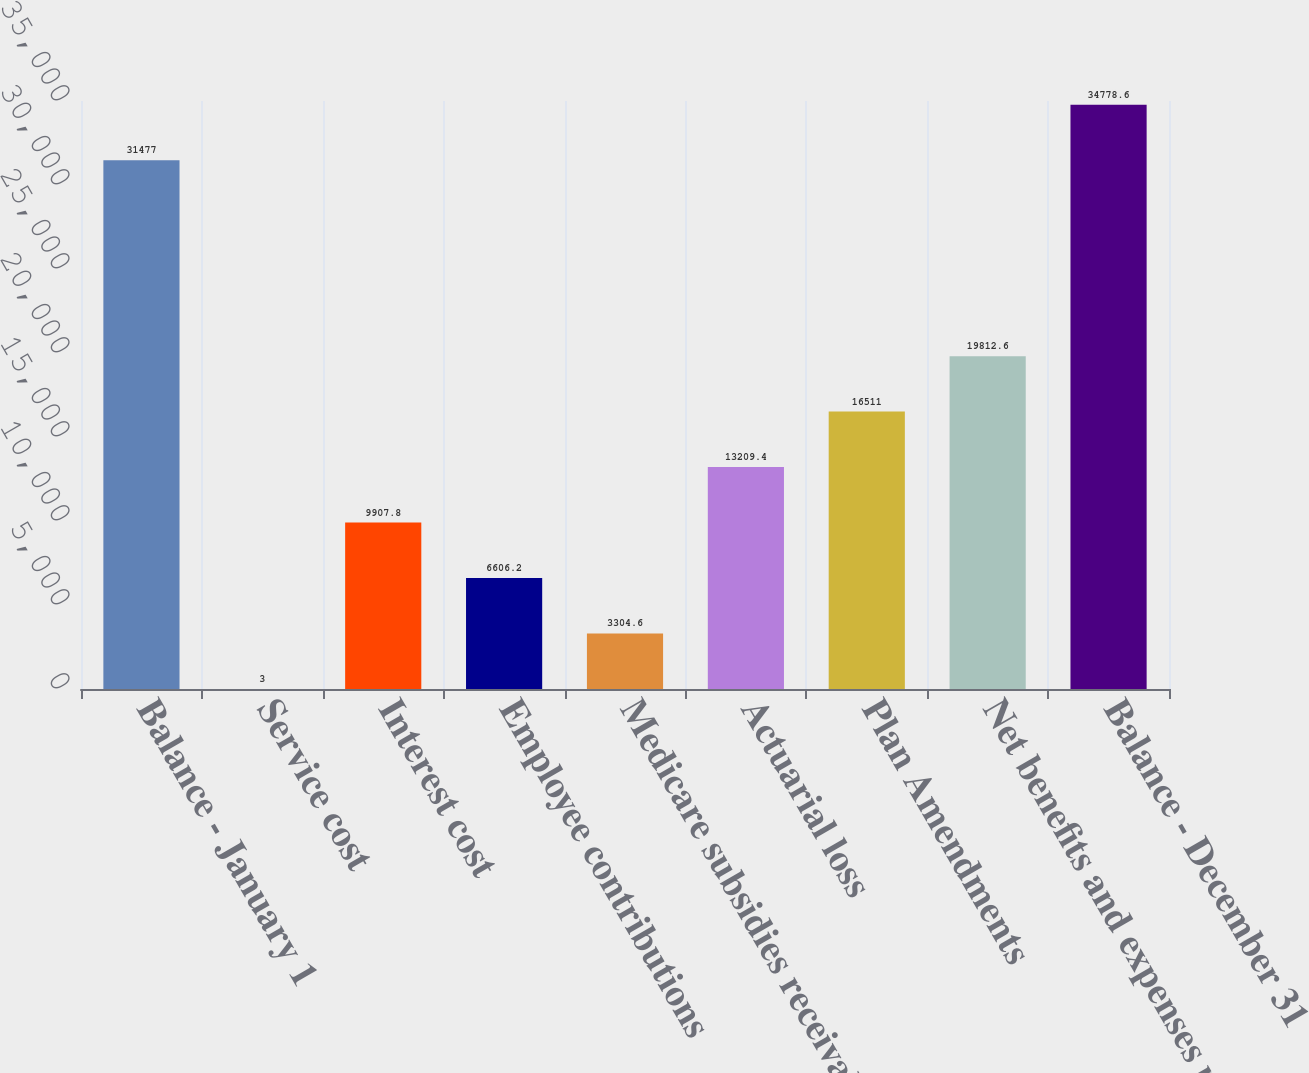Convert chart. <chart><loc_0><loc_0><loc_500><loc_500><bar_chart><fcel>Balance - January 1<fcel>Service cost<fcel>Interest cost<fcel>Employee contributions<fcel>Medicare subsidies receivable<fcel>Actuarial loss<fcel>Plan Amendments<fcel>Net benefits and expenses paid<fcel>Balance - December 31<nl><fcel>31477<fcel>3<fcel>9907.8<fcel>6606.2<fcel>3304.6<fcel>13209.4<fcel>16511<fcel>19812.6<fcel>34778.6<nl></chart> 